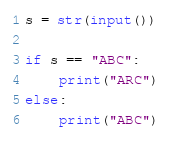<code> <loc_0><loc_0><loc_500><loc_500><_Python_>s = str(input())

if s == "ABC":
    print("ARC")
else:
    print("ABC")</code> 